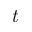<formula> <loc_0><loc_0><loc_500><loc_500>t</formula> 